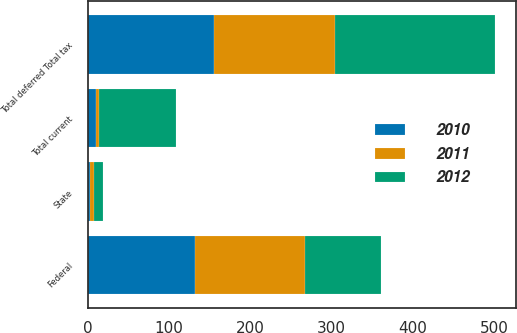Convert chart. <chart><loc_0><loc_0><loc_500><loc_500><stacked_bar_chart><ecel><fcel>State<fcel>Total current<fcel>Federal<fcel>Total deferred Total tax<nl><fcel>2012<fcel>11<fcel>94<fcel>94<fcel>198<nl><fcel>2011<fcel>4<fcel>4<fcel>135<fcel>149<nl><fcel>2010<fcel>3<fcel>10<fcel>132<fcel>155<nl></chart> 